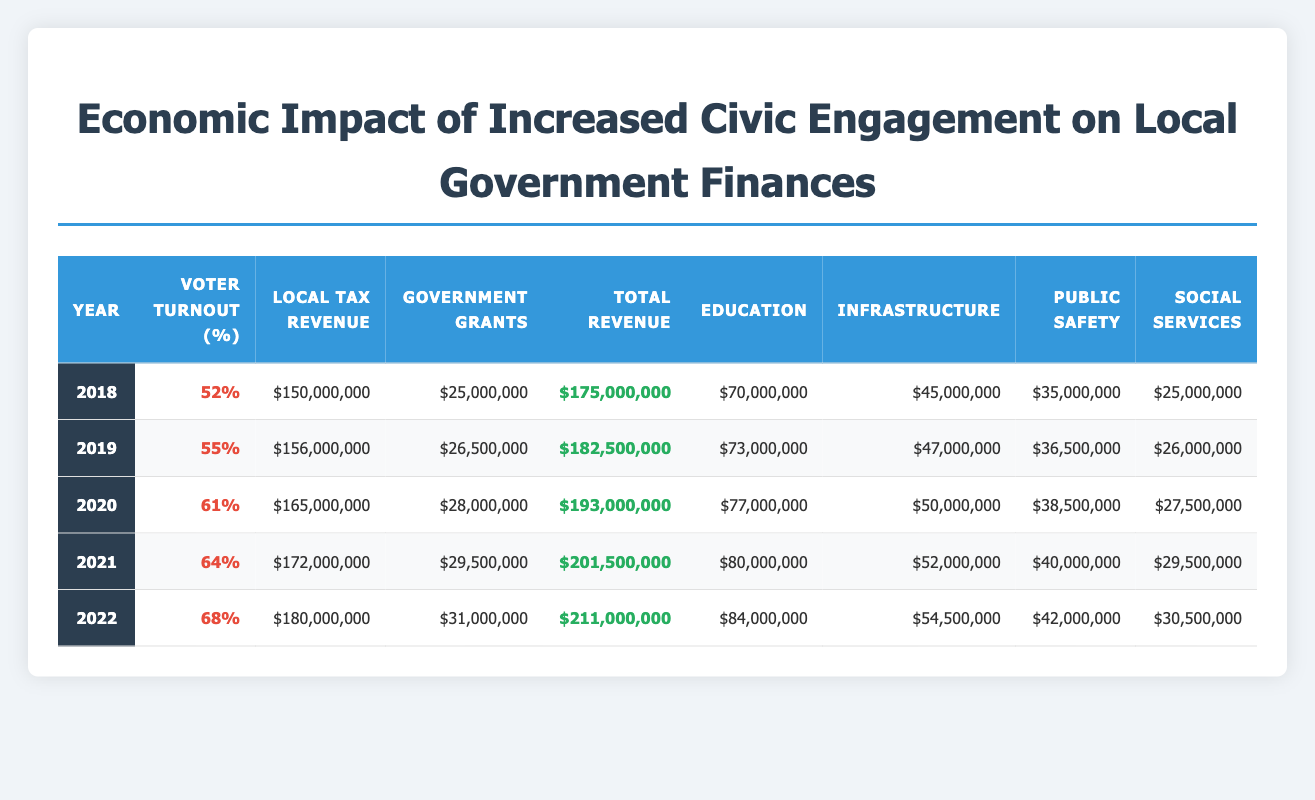What was the local tax revenue in 2020? The table shows that the local tax revenue for the year 2020 is listed directly in the corresponding row under 'Local Tax Revenue'.
Answer: 165000000 What percentage of voter turnout was recorded in 2022? According to the table, the voter turnout percentage for the year 2022 is found in the respective column for Voter Turnout, which shows a value of 68%.
Answer: 68 What was the total revenue in 2021 compared to 2019? The total revenue for 2021 is $201,500,000 and for 2019 it is $182,500,000. To compare, we can see that 2021 had more total revenue than 2019.
Answer: Yes What is the difference in total revenue between 2020 and 2022? From the table, the total revenue for 2020 is $193,000,000 and for 2022 is $211,000,000. The difference is $211,000,000 - $193,000,000 = $18,000,000.
Answer: 18000000 What was the average education expenditure over the years 2018 to 2022? The education expenditures for the years 2018, 2019, 2020, 2021, and 2022 are $70,000,000; $73,000,000; $77,000,000; $80,000,000; and $84,000,000 respectively. The average is calculated by summing these and then dividing by the number of years: (70 + 73 + 77 + 80 + 84) / 5 = 76.8 million.
Answer: 76800000 In which year did the local tax revenue first exceed $170 million? The local tax revenue exceeds $170 million for the first time in 2020, where it is recorded at $165 million, but it exceeds it in 2021 with $172 million listed.
Answer: 2021 Did government grants increase each year from 2018 to 2022? By examining the government grants column, we see that the amounts increase each year: $25,000,000 (2018), $26,500,000 (2019), $28,000,000 (2020), $29,500,000 (2021), and $31,000,000 (2022). Hence, it is true that they increased each year.
Answer: Yes What was the total expenditure on infrastructure in 2019 and 2021 combined? For 2019 the infrastructure expenditure is $47,000,000 and for 2021 it is $52,000,000. The combined total is $47,000,000 + $52,000,000 = $99,000,000.
Answer: 99000000 Which year had the highest expenditure on public safety, and what was the amount? Looking through the public safety expenditures listed, it appears that 2022 has the highest expenditure of $42,000,000.
Answer: 2022, 42000000 